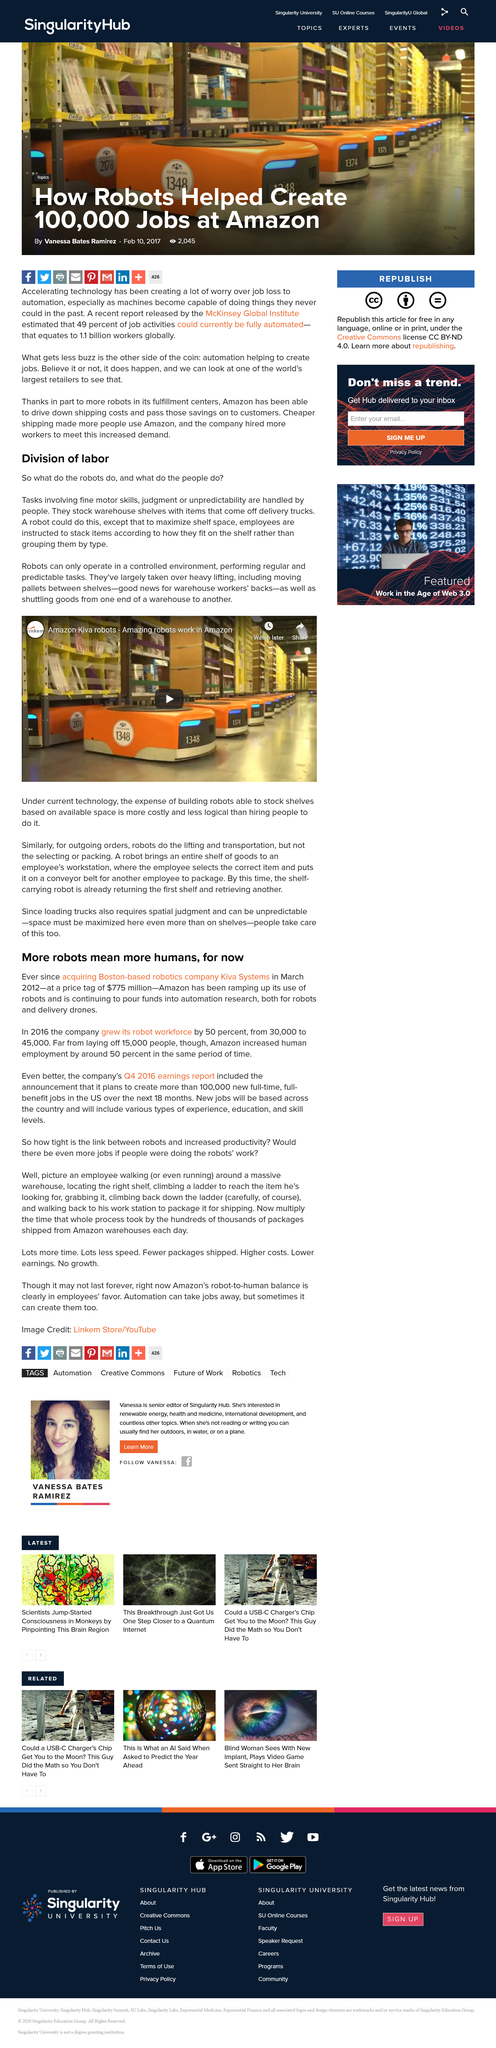Point out several critical features in this image. The company's robot workforce increased by 50% in the last year, demonstrating significant growth in the use of automation technology. Robots operate only in a controlled environment, performing regular and predictable tasks according to a predetermined set of instructions. The title of this section is "More robots mean more humans, for now. Over the next 18 months, they plan to create 100,000 new full-time, full-benefit jobs in the United States. Employees are instructed to stack items on the shelf in a manner that aligns with how the items fit, rather than grouping them by type. 